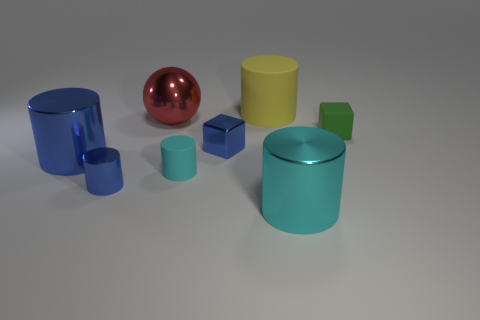There is a tiny shiny object that is the same color as the small metal cylinder; what is its shape?
Provide a short and direct response. Cube. Is the tiny metallic cube the same color as the tiny metallic cylinder?
Give a very brief answer. Yes. What number of big objects are the same color as the small shiny cylinder?
Give a very brief answer. 1. There is a tiny cylinder that is to the left of the big red metallic sphere; does it have the same color as the shiny cube?
Make the answer very short. Yes. There is a block that is the same color as the small shiny cylinder; what is its size?
Give a very brief answer. Small. There is a big cyan thing that is on the right side of the cyan cylinder that is on the left side of the yellow rubber cylinder; what number of metallic blocks are on the right side of it?
Give a very brief answer. 0. What size is the other cyan thing that is the same shape as the big cyan metal object?
Ensure brevity in your answer.  Small. Is there any other thing that has the same size as the ball?
Your response must be concise. Yes. Do the big cylinder that is behind the green block and the big cyan cylinder have the same material?
Provide a succinct answer. No. What color is the small matte object that is the same shape as the big yellow object?
Provide a short and direct response. Cyan. 